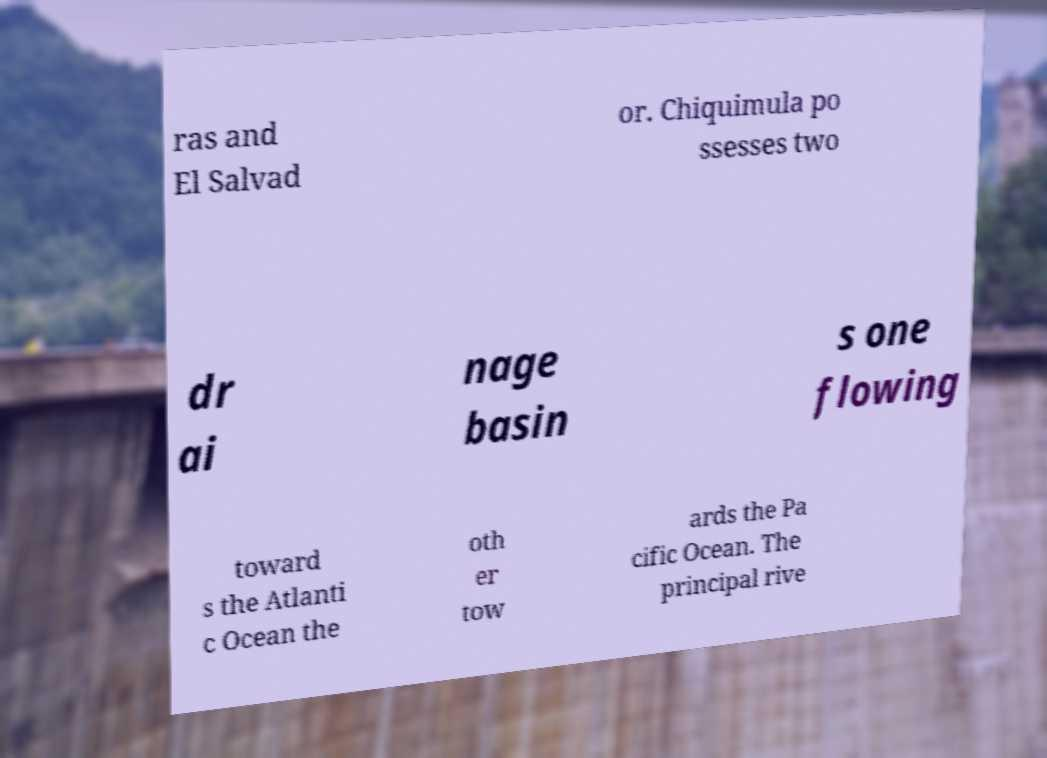Could you extract and type out the text from this image? ras and El Salvad or. Chiquimula po ssesses two dr ai nage basin s one flowing toward s the Atlanti c Ocean the oth er tow ards the Pa cific Ocean. The principal rive 